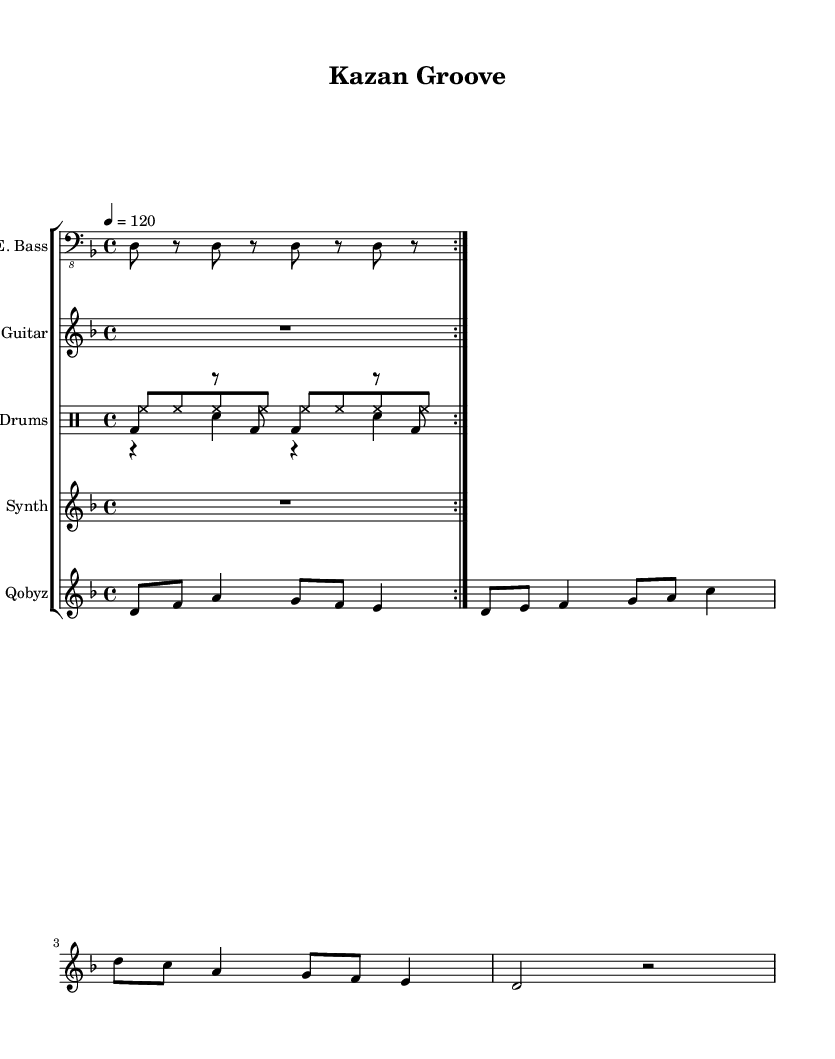What is the key signature of this music? The key signature shows one flat, indicating that the key is D minor.
Answer: D minor What is the time signature used in this piece? The time signature marked on the sheet indicates 4 beats per measure, which is typical for funk music.
Answer: 4/4 What is the tempo marking for this piece? The tempo is indicated as quarter note equals 120 beats per minute, which guides the speed of the music.
Answer: 120 How many times is the electric bass part repeated? The electric bass part is marked to be repeated twice, as indicated by the volta symbol in the score.
Answer: 2 What rhythmic pattern is used in the drum kit part? The drum kit combines kick drum, snare drum, and hi-hat patterns, which create a syncopated funk groove typical in this genre.
Answer: Funk groove How many different instruments are featured in this score? The score includes five distinct instrument parts: electric bass, electric guitar, drums, synthesizer, and qobyz.
Answer: 5 What is the role of the qobyz in this composition? The qobyz plays melodic lines, incorporating traditional Tatar melodies, which adds cultural depth to the funk fusion style.
Answer: Melodic lines 